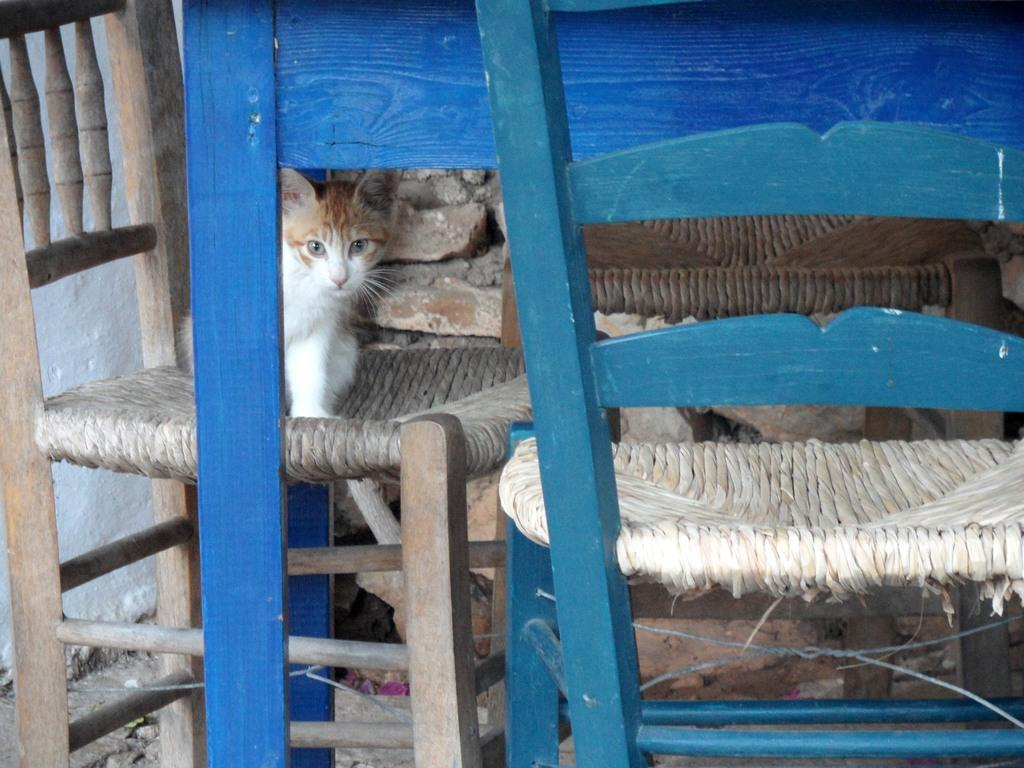What animal is present in the image? There is a cat in the image. What is the cat doing in the image? The cat is standing on a chair and staring. Are there any other chairs visible in the image? Yes, there is another chair beside the cat. Can you see the moon in the image? No, the moon is not present in the image. Is the cat touching the other chair in the image? The image does not show the cat touching the other chair, but it is close to it. 